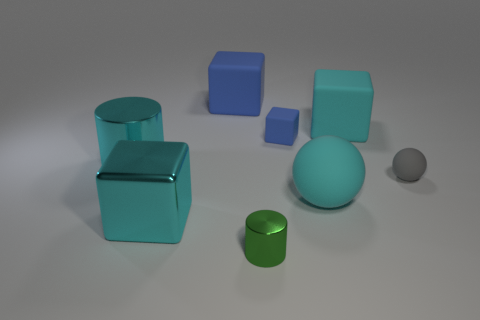What number of other objects are there of the same color as the metallic block?
Your answer should be very brief. 3. What number of metal things are either brown blocks or cubes?
Give a very brief answer. 1. Is the color of the rubber ball that is in front of the gray matte ball the same as the tiny rubber object behind the tiny gray thing?
Your answer should be very brief. No. There is another blue thing that is the same shape as the big blue thing; what size is it?
Your answer should be compact. Small. Are there more cyan balls right of the small shiny cylinder than brown rubber spheres?
Give a very brief answer. Yes. Do the large cyan block in front of the large cyan metal cylinder and the small green cylinder have the same material?
Provide a succinct answer. Yes. What size is the cylinder in front of the tiny rubber object right of the cyan matte object in front of the big shiny cylinder?
Make the answer very short. Small. There is a green cylinder that is made of the same material as the large cyan cylinder; what is its size?
Give a very brief answer. Small. What color is the shiny thing that is behind the green metal thing and in front of the big ball?
Provide a succinct answer. Cyan. There is a blue rubber object that is left of the tiny green cylinder; is its shape the same as the small object that is on the right side of the cyan rubber block?
Ensure brevity in your answer.  No. 